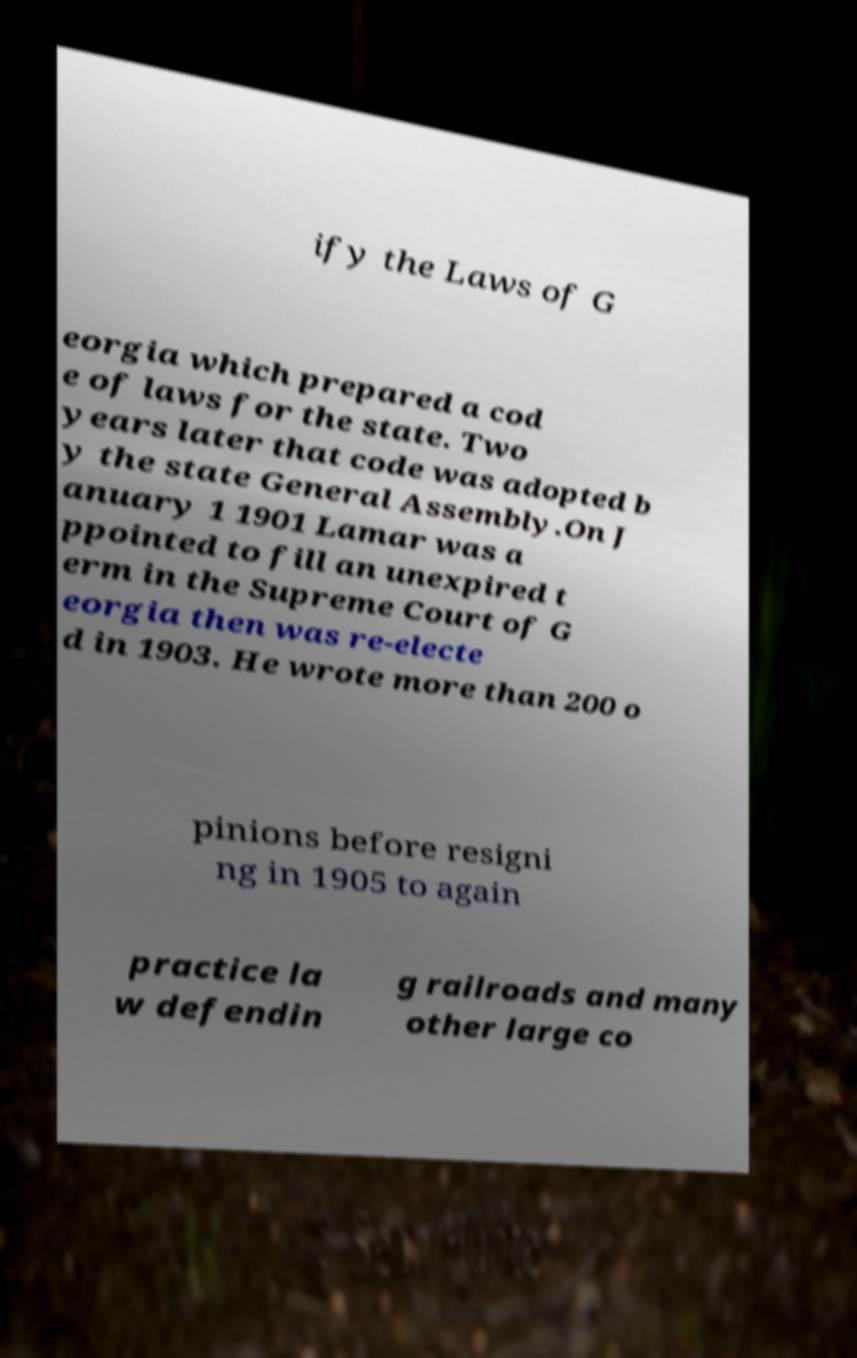Please read and relay the text visible in this image. What does it say? ify the Laws of G eorgia which prepared a cod e of laws for the state. Two years later that code was adopted b y the state General Assembly.On J anuary 1 1901 Lamar was a ppointed to fill an unexpired t erm in the Supreme Court of G eorgia then was re-electe d in 1903. He wrote more than 200 o pinions before resigni ng in 1905 to again practice la w defendin g railroads and many other large co 